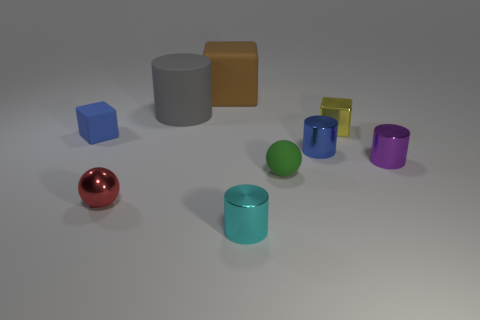The blue thing right of the small sphere that is behind the red metallic sphere is what shape?
Offer a very short reply. Cylinder. There is a blue object that is on the right side of the tiny red shiny object; what size is it?
Your answer should be compact. Small. Is the green sphere made of the same material as the red thing?
Give a very brief answer. No. What is the shape of the small green object that is made of the same material as the large gray cylinder?
Your response must be concise. Sphere. Are there any other things that have the same color as the large matte cylinder?
Provide a succinct answer. No. What is the color of the ball that is in front of the small green thing?
Provide a succinct answer. Red. There is a small block that is left of the green ball; is it the same color as the large rubber block?
Provide a short and direct response. No. What material is the tiny blue object that is the same shape as the yellow thing?
Ensure brevity in your answer.  Rubber. How many green metallic things are the same size as the gray matte object?
Give a very brief answer. 0. What shape is the big gray rubber object?
Offer a very short reply. Cylinder. 